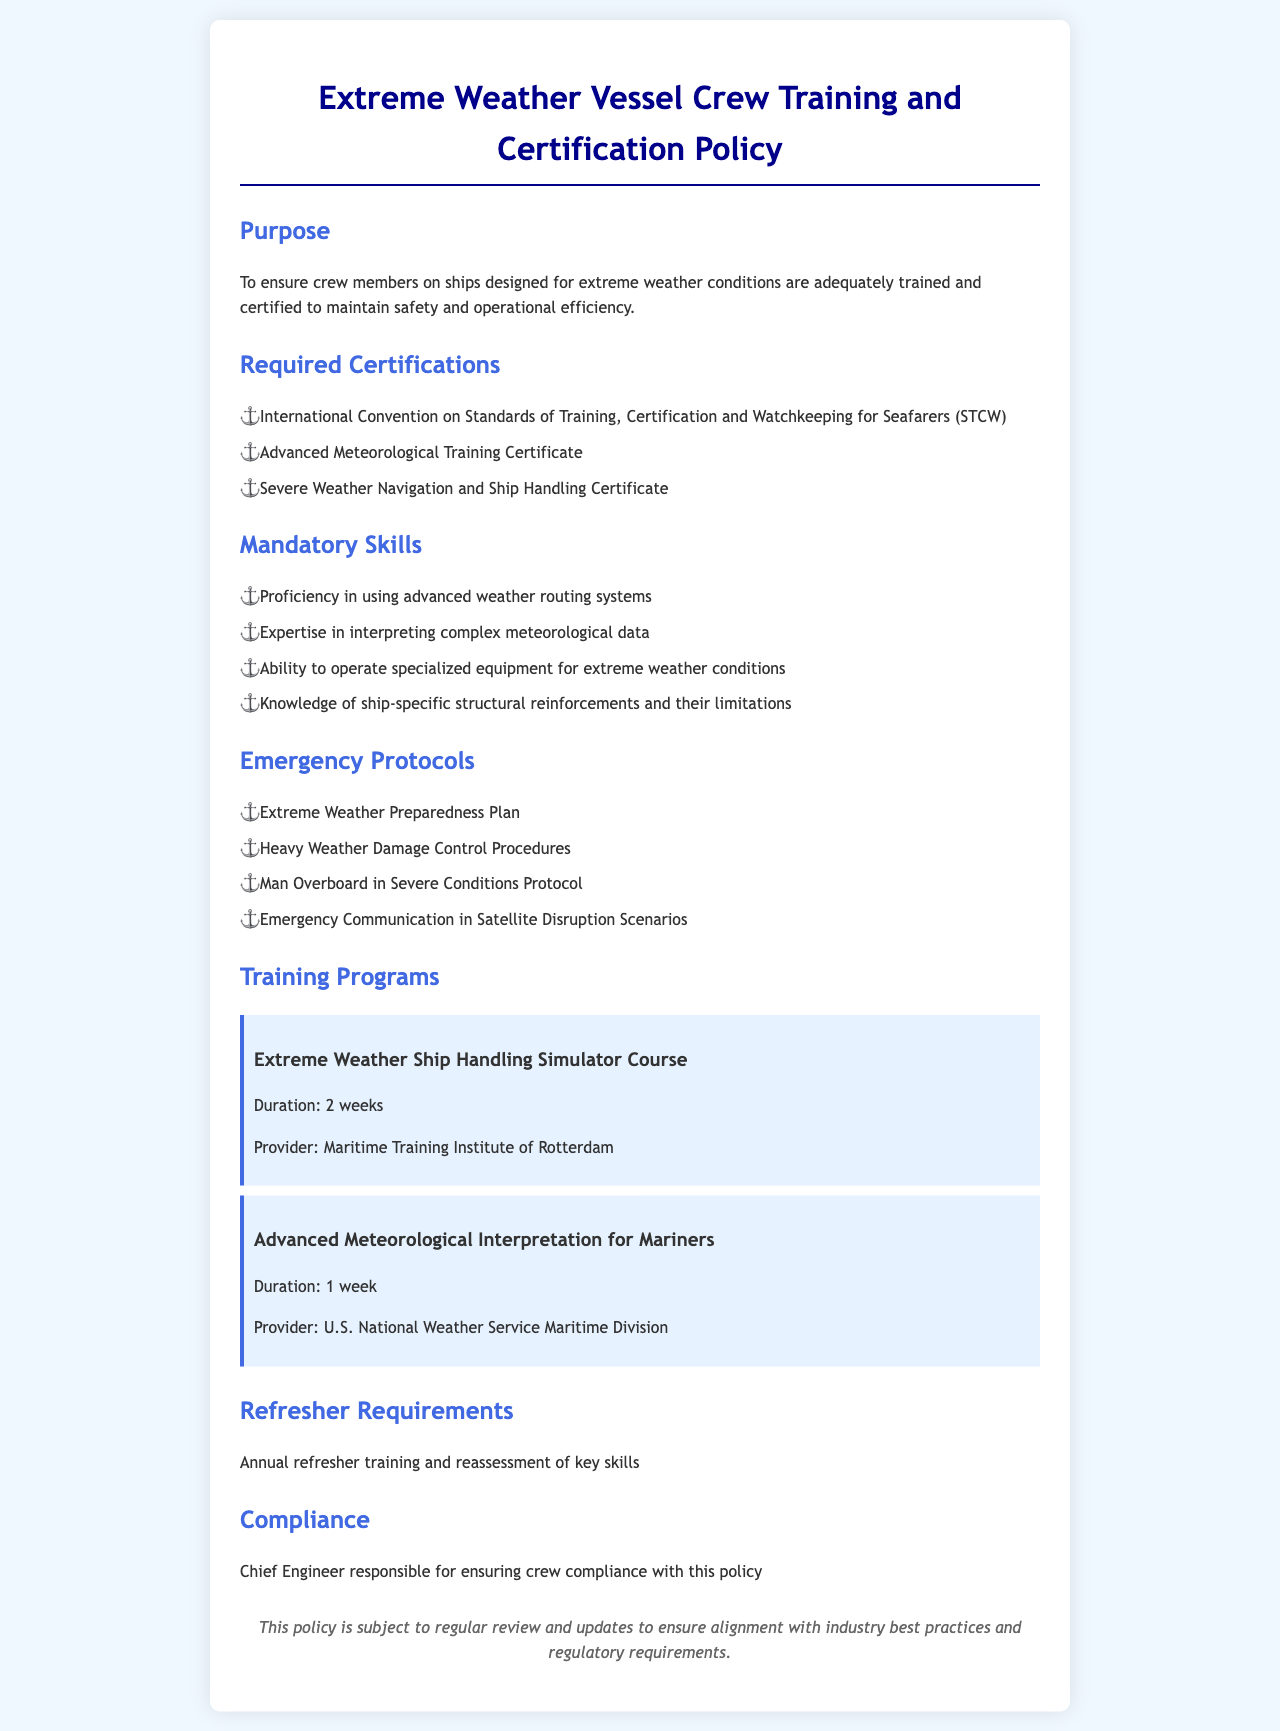What is the purpose of the policy? The purpose is to ensure crew members are adequately trained and certified to maintain safety and operational efficiency on ships designed for extreme weather conditions.
Answer: To ensure crew members are adequately trained and certified to maintain safety and operational efficiency What is one of the required certifications? This is found under "Required Certifications" and lists several key qualifications for crew members.
Answer: International Convention on Standards of Training, Certification and Watchkeeping for Seafarers (STCW) How long is the Extreme Weather Ship Handling Simulator Course? The duration of this course is specified under "Training Programs".
Answer: 2 weeks Who is responsible for ensuring compliance with this policy? This information is provided in the "Compliance" section, listing the responsible party for adherence to the policy.
Answer: Chief Engineer Name one mandatory skill needed for crew members. This information is available in the "Mandatory Skills" section, outlining necessary expertise for the crew.
Answer: Proficiency in using advanced weather routing systems What emergency protocol addresses man overboard situations? The emergency protocols are listed in the relevant section, including specific scenarios that need attention.
Answer: Man Overboard in Severe Conditions Protocol What is the frequency of refresher training requirements? This is stated in the "Refresher Requirements" section, which specifies how often this reassessment occurs.
Answer: Annual What provider offers the Advanced Meteorological Interpretation for Mariners course? The document lists training program providers, specifying details for each course, including who offers it.
Answer: U.S. National Weather Service Maritime Division 